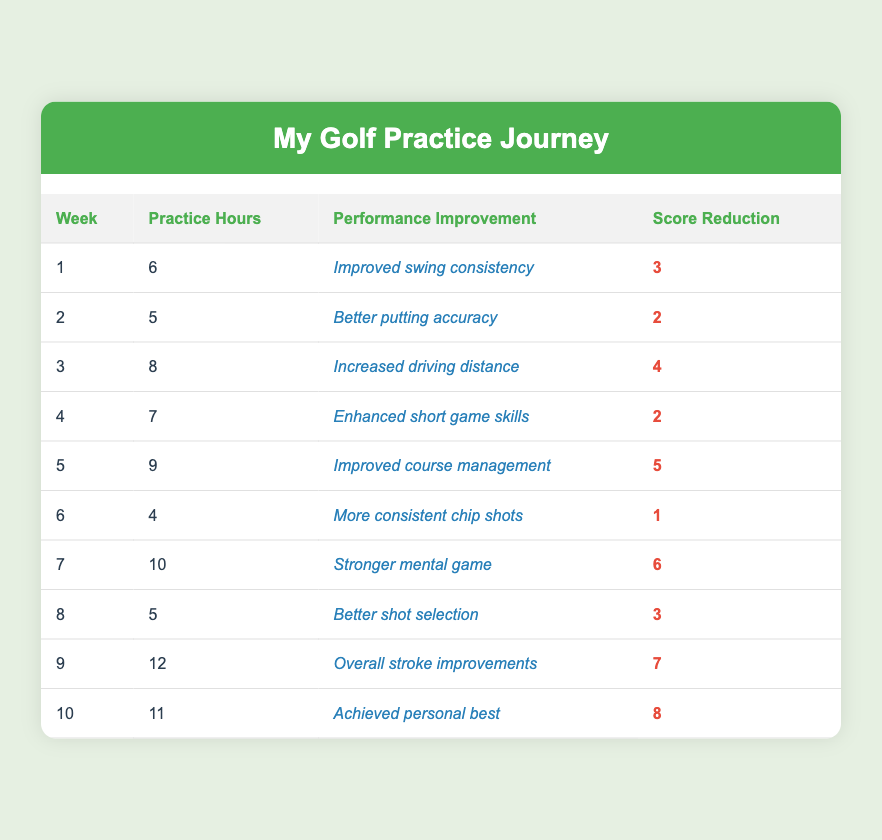What was the highest score reduction in a week? By looking at the "Score Reduction" column, the highest value is 8, which occurred in week 10.
Answer: 8 In which week did I practice the most hours? The "Practice Hours" column shows that the highest number is 12, found in week 9.
Answer: Week 9 What is the average score reduction over all weeks? To find the average, sum all the score reductions (3 + 2 + 4 + 2 + 5 + 1 + 6 + 3 + 7 + 8 = 41) and divide by the number of weeks (10): 41 / 10 = 4.1.
Answer: 4.1 Did my practice hours ever exceed 10 hours in a week? By checking the "Practice Hours" column, I see that week 7 had 10 hours and week 9 had 12 hours, confirming that yes, I practiced more than 10 hours.
Answer: Yes In which week did I see the most significant performance improvement? The "Performance Improvement" column shows improvements related to the score reductions. Week 10's performance improvement led to an 8-point reduction, which is the biggest score change.
Answer: Week 10 What was the average number of practice hours over the ten weeks? First, total the practice hours (6 + 5 + 8 + 7 + 9 + 4 + 10 + 5 + 12 + 11 = 77), and divide by the number of weeks (10): 77 / 10 = 7.7.
Answer: 7.7 Was there any week where the performance improvement mentioned related to putting? Looking at the "Performance Improvement" column, week 2 lists "Better putting accuracy," confirming that there was such a week.
Answer: Yes Which week had the least practice hours and how much was it? The "Practice Hours" column shows that week 6 had the least practice hours at 4.
Answer: Week 6, 4 hours How many performance improvements related to distance occurred in this practice period? Reviewing the "Performance Improvement" column, only week 3 ("Increased driving distance") reflects performance improvement focused on distance.
Answer: 1 improvement What was the pattern of score reductions in relation to practice hours over the weeks? By analyzing the data, it's seen that score reductions tend to increase with higher practice hours. For example, week 10 shows both the highest hours and score reduction.
Answer: Increasing pattern Did I improve my mental game, and in which week did it happen? Indeed, "Stronger mental game" is noted in week 7 as an improvement, confirming this development.
Answer: Week 7 